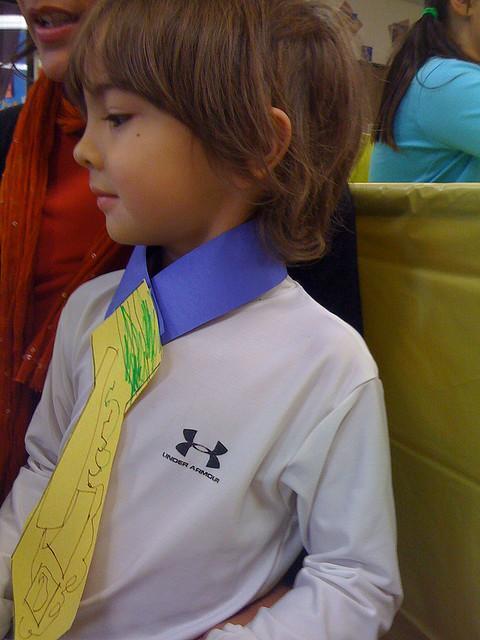What is the small child's tie made out of?
From the following four choices, select the correct answer to address the question.
Options: Plastic, paper, metal, cotton. Paper. 